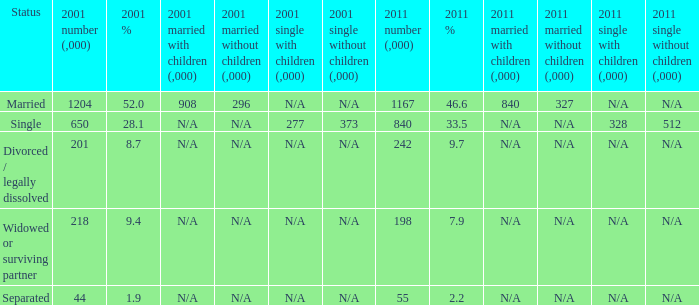What is the lowest 2011 number (,000)? 55.0. 